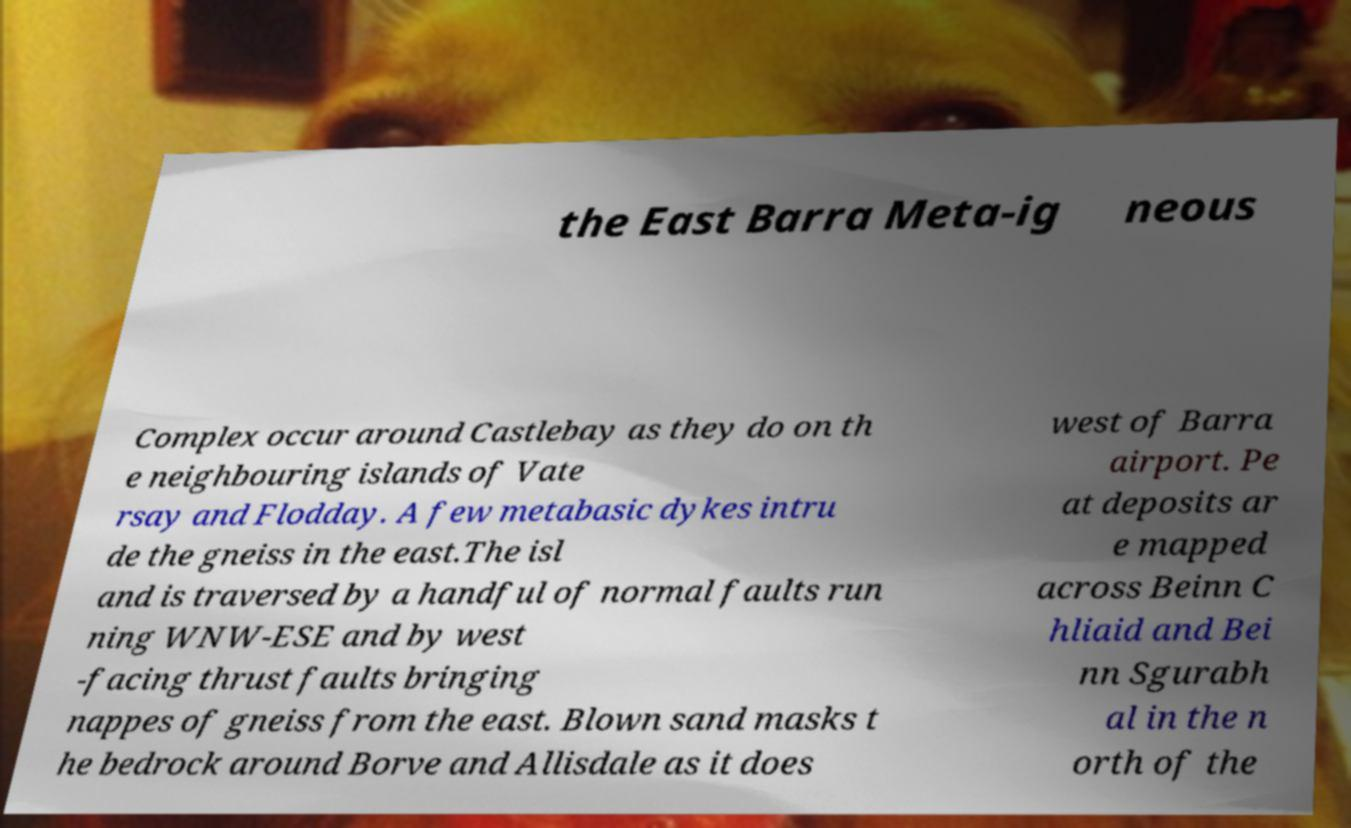For documentation purposes, I need the text within this image transcribed. Could you provide that? the East Barra Meta-ig neous Complex occur around Castlebay as they do on th e neighbouring islands of Vate rsay and Flodday. A few metabasic dykes intru de the gneiss in the east.The isl and is traversed by a handful of normal faults run ning WNW-ESE and by west -facing thrust faults bringing nappes of gneiss from the east. Blown sand masks t he bedrock around Borve and Allisdale as it does west of Barra airport. Pe at deposits ar e mapped across Beinn C hliaid and Bei nn Sgurabh al in the n orth of the 